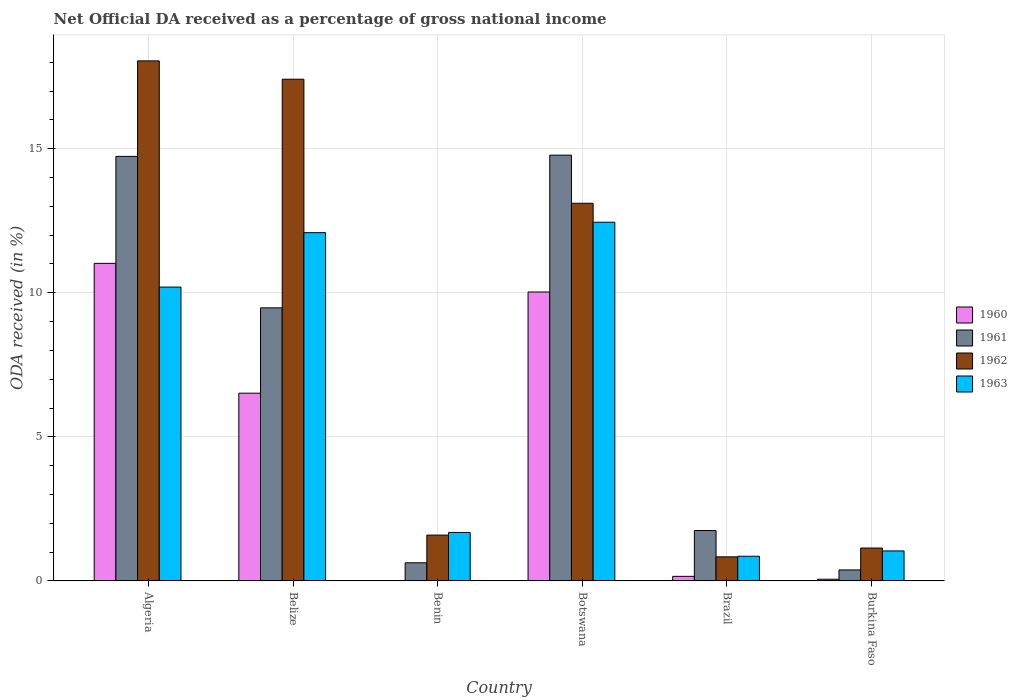How many different coloured bars are there?
Offer a very short reply. 4. Are the number of bars per tick equal to the number of legend labels?
Your answer should be compact. Yes. What is the label of the 3rd group of bars from the left?
Provide a succinct answer. Benin. What is the net official DA received in 1961 in Benin?
Keep it short and to the point. 0.63. Across all countries, what is the maximum net official DA received in 1961?
Offer a terse response. 14.78. Across all countries, what is the minimum net official DA received in 1960?
Offer a terse response. 0.01. In which country was the net official DA received in 1963 maximum?
Provide a succinct answer. Botswana. In which country was the net official DA received in 1960 minimum?
Provide a short and direct response. Benin. What is the total net official DA received in 1961 in the graph?
Your response must be concise. 41.75. What is the difference between the net official DA received in 1960 in Belize and that in Burkina Faso?
Keep it short and to the point. 6.46. What is the difference between the net official DA received in 1963 in Botswana and the net official DA received in 1962 in Belize?
Your response must be concise. -4.96. What is the average net official DA received in 1961 per country?
Provide a short and direct response. 6.96. What is the difference between the net official DA received of/in 1960 and net official DA received of/in 1962 in Algeria?
Ensure brevity in your answer.  -7.03. What is the ratio of the net official DA received in 1962 in Algeria to that in Brazil?
Provide a succinct answer. 21.59. Is the difference between the net official DA received in 1960 in Algeria and Benin greater than the difference between the net official DA received in 1962 in Algeria and Benin?
Give a very brief answer. No. What is the difference between the highest and the second highest net official DA received in 1963?
Offer a terse response. -2.25. What is the difference between the highest and the lowest net official DA received in 1961?
Give a very brief answer. 14.4. In how many countries, is the net official DA received in 1961 greater than the average net official DA received in 1961 taken over all countries?
Make the answer very short. 3. Is the sum of the net official DA received in 1962 in Belize and Burkina Faso greater than the maximum net official DA received in 1960 across all countries?
Give a very brief answer. Yes. Is it the case that in every country, the sum of the net official DA received in 1960 and net official DA received in 1962 is greater than the sum of net official DA received in 1961 and net official DA received in 1963?
Offer a very short reply. No. Is it the case that in every country, the sum of the net official DA received in 1961 and net official DA received in 1963 is greater than the net official DA received in 1960?
Your answer should be compact. Yes. Are the values on the major ticks of Y-axis written in scientific E-notation?
Give a very brief answer. No. Does the graph contain grids?
Provide a succinct answer. Yes. Where does the legend appear in the graph?
Your response must be concise. Center right. How are the legend labels stacked?
Provide a succinct answer. Vertical. What is the title of the graph?
Your answer should be compact. Net Official DA received as a percentage of gross national income. What is the label or title of the Y-axis?
Keep it short and to the point. ODA received (in %). What is the ODA received (in %) of 1960 in Algeria?
Provide a succinct answer. 11.02. What is the ODA received (in %) in 1961 in Algeria?
Your answer should be very brief. 14.73. What is the ODA received (in %) of 1962 in Algeria?
Make the answer very short. 18.05. What is the ODA received (in %) in 1963 in Algeria?
Give a very brief answer. 10.2. What is the ODA received (in %) of 1960 in Belize?
Keep it short and to the point. 6.52. What is the ODA received (in %) in 1961 in Belize?
Offer a terse response. 9.48. What is the ODA received (in %) of 1962 in Belize?
Provide a short and direct response. 17.41. What is the ODA received (in %) in 1963 in Belize?
Provide a short and direct response. 12.09. What is the ODA received (in %) in 1960 in Benin?
Make the answer very short. 0.01. What is the ODA received (in %) in 1961 in Benin?
Your answer should be compact. 0.63. What is the ODA received (in %) in 1962 in Benin?
Offer a very short reply. 1.59. What is the ODA received (in %) of 1963 in Benin?
Your answer should be very brief. 1.68. What is the ODA received (in %) of 1960 in Botswana?
Give a very brief answer. 10.03. What is the ODA received (in %) of 1961 in Botswana?
Provide a short and direct response. 14.78. What is the ODA received (in %) in 1962 in Botswana?
Offer a very short reply. 13.11. What is the ODA received (in %) of 1963 in Botswana?
Make the answer very short. 12.45. What is the ODA received (in %) of 1960 in Brazil?
Your answer should be very brief. 0.16. What is the ODA received (in %) of 1961 in Brazil?
Offer a very short reply. 1.75. What is the ODA received (in %) in 1962 in Brazil?
Provide a short and direct response. 0.84. What is the ODA received (in %) in 1963 in Brazil?
Your answer should be compact. 0.86. What is the ODA received (in %) of 1960 in Burkina Faso?
Offer a terse response. 0.06. What is the ODA received (in %) of 1961 in Burkina Faso?
Make the answer very short. 0.38. What is the ODA received (in %) in 1962 in Burkina Faso?
Your answer should be very brief. 1.14. What is the ODA received (in %) of 1963 in Burkina Faso?
Your response must be concise. 1.04. Across all countries, what is the maximum ODA received (in %) in 1960?
Give a very brief answer. 11.02. Across all countries, what is the maximum ODA received (in %) in 1961?
Offer a terse response. 14.78. Across all countries, what is the maximum ODA received (in %) of 1962?
Your answer should be very brief. 18.05. Across all countries, what is the maximum ODA received (in %) in 1963?
Provide a short and direct response. 12.45. Across all countries, what is the minimum ODA received (in %) in 1960?
Provide a succinct answer. 0.01. Across all countries, what is the minimum ODA received (in %) of 1961?
Offer a very short reply. 0.38. Across all countries, what is the minimum ODA received (in %) of 1962?
Your answer should be compact. 0.84. Across all countries, what is the minimum ODA received (in %) in 1963?
Make the answer very short. 0.86. What is the total ODA received (in %) of 1960 in the graph?
Make the answer very short. 27.79. What is the total ODA received (in %) in 1961 in the graph?
Your response must be concise. 41.75. What is the total ODA received (in %) of 1962 in the graph?
Ensure brevity in your answer.  52.14. What is the total ODA received (in %) in 1963 in the graph?
Ensure brevity in your answer.  38.32. What is the difference between the ODA received (in %) in 1960 in Algeria and that in Belize?
Give a very brief answer. 4.51. What is the difference between the ODA received (in %) of 1961 in Algeria and that in Belize?
Make the answer very short. 5.26. What is the difference between the ODA received (in %) of 1962 in Algeria and that in Belize?
Give a very brief answer. 0.64. What is the difference between the ODA received (in %) of 1963 in Algeria and that in Belize?
Offer a very short reply. -1.89. What is the difference between the ODA received (in %) in 1960 in Algeria and that in Benin?
Offer a terse response. 11.01. What is the difference between the ODA received (in %) of 1961 in Algeria and that in Benin?
Give a very brief answer. 14.1. What is the difference between the ODA received (in %) in 1962 in Algeria and that in Benin?
Your answer should be very brief. 16.46. What is the difference between the ODA received (in %) of 1963 in Algeria and that in Benin?
Give a very brief answer. 8.52. What is the difference between the ODA received (in %) in 1961 in Algeria and that in Botswana?
Your response must be concise. -0.04. What is the difference between the ODA received (in %) of 1962 in Algeria and that in Botswana?
Your answer should be very brief. 4.94. What is the difference between the ODA received (in %) in 1963 in Algeria and that in Botswana?
Provide a succinct answer. -2.25. What is the difference between the ODA received (in %) of 1960 in Algeria and that in Brazil?
Your answer should be very brief. 10.86. What is the difference between the ODA received (in %) in 1961 in Algeria and that in Brazil?
Keep it short and to the point. 12.98. What is the difference between the ODA received (in %) of 1962 in Algeria and that in Brazil?
Ensure brevity in your answer.  17.21. What is the difference between the ODA received (in %) of 1963 in Algeria and that in Brazil?
Ensure brevity in your answer.  9.34. What is the difference between the ODA received (in %) of 1960 in Algeria and that in Burkina Faso?
Your response must be concise. 10.96. What is the difference between the ODA received (in %) of 1961 in Algeria and that in Burkina Faso?
Your answer should be compact. 14.35. What is the difference between the ODA received (in %) in 1962 in Algeria and that in Burkina Faso?
Your answer should be very brief. 16.91. What is the difference between the ODA received (in %) of 1963 in Algeria and that in Burkina Faso?
Offer a terse response. 9.16. What is the difference between the ODA received (in %) in 1960 in Belize and that in Benin?
Ensure brevity in your answer.  6.51. What is the difference between the ODA received (in %) of 1961 in Belize and that in Benin?
Provide a short and direct response. 8.85. What is the difference between the ODA received (in %) in 1962 in Belize and that in Benin?
Ensure brevity in your answer.  15.82. What is the difference between the ODA received (in %) in 1963 in Belize and that in Benin?
Provide a succinct answer. 10.4. What is the difference between the ODA received (in %) in 1960 in Belize and that in Botswana?
Keep it short and to the point. -3.51. What is the difference between the ODA received (in %) in 1961 in Belize and that in Botswana?
Offer a very short reply. -5.3. What is the difference between the ODA received (in %) of 1962 in Belize and that in Botswana?
Provide a succinct answer. 4.31. What is the difference between the ODA received (in %) in 1963 in Belize and that in Botswana?
Offer a terse response. -0.36. What is the difference between the ODA received (in %) in 1960 in Belize and that in Brazil?
Ensure brevity in your answer.  6.36. What is the difference between the ODA received (in %) in 1961 in Belize and that in Brazil?
Give a very brief answer. 7.73. What is the difference between the ODA received (in %) of 1962 in Belize and that in Brazil?
Give a very brief answer. 16.58. What is the difference between the ODA received (in %) of 1963 in Belize and that in Brazil?
Ensure brevity in your answer.  11.23. What is the difference between the ODA received (in %) of 1960 in Belize and that in Burkina Faso?
Provide a succinct answer. 6.46. What is the difference between the ODA received (in %) in 1961 in Belize and that in Burkina Faso?
Provide a short and direct response. 9.1. What is the difference between the ODA received (in %) in 1962 in Belize and that in Burkina Faso?
Offer a terse response. 16.27. What is the difference between the ODA received (in %) of 1963 in Belize and that in Burkina Faso?
Give a very brief answer. 11.05. What is the difference between the ODA received (in %) in 1960 in Benin and that in Botswana?
Make the answer very short. -10.02. What is the difference between the ODA received (in %) in 1961 in Benin and that in Botswana?
Provide a succinct answer. -14.15. What is the difference between the ODA received (in %) in 1962 in Benin and that in Botswana?
Your answer should be compact. -11.52. What is the difference between the ODA received (in %) of 1963 in Benin and that in Botswana?
Your response must be concise. -10.77. What is the difference between the ODA received (in %) of 1960 in Benin and that in Brazil?
Offer a terse response. -0.15. What is the difference between the ODA received (in %) of 1961 in Benin and that in Brazil?
Make the answer very short. -1.12. What is the difference between the ODA received (in %) of 1962 in Benin and that in Brazil?
Ensure brevity in your answer.  0.76. What is the difference between the ODA received (in %) of 1963 in Benin and that in Brazil?
Provide a succinct answer. 0.83. What is the difference between the ODA received (in %) of 1960 in Benin and that in Burkina Faso?
Give a very brief answer. -0.05. What is the difference between the ODA received (in %) in 1961 in Benin and that in Burkina Faso?
Provide a short and direct response. 0.25. What is the difference between the ODA received (in %) of 1962 in Benin and that in Burkina Faso?
Provide a succinct answer. 0.45. What is the difference between the ODA received (in %) in 1963 in Benin and that in Burkina Faso?
Provide a succinct answer. 0.64. What is the difference between the ODA received (in %) of 1960 in Botswana and that in Brazil?
Make the answer very short. 9.87. What is the difference between the ODA received (in %) of 1961 in Botswana and that in Brazil?
Give a very brief answer. 13.03. What is the difference between the ODA received (in %) in 1962 in Botswana and that in Brazil?
Give a very brief answer. 12.27. What is the difference between the ODA received (in %) in 1963 in Botswana and that in Brazil?
Keep it short and to the point. 11.59. What is the difference between the ODA received (in %) of 1960 in Botswana and that in Burkina Faso?
Keep it short and to the point. 9.97. What is the difference between the ODA received (in %) in 1961 in Botswana and that in Burkina Faso?
Ensure brevity in your answer.  14.39. What is the difference between the ODA received (in %) of 1962 in Botswana and that in Burkina Faso?
Make the answer very short. 11.97. What is the difference between the ODA received (in %) in 1963 in Botswana and that in Burkina Faso?
Make the answer very short. 11.41. What is the difference between the ODA received (in %) of 1960 in Brazil and that in Burkina Faso?
Your response must be concise. 0.1. What is the difference between the ODA received (in %) of 1961 in Brazil and that in Burkina Faso?
Provide a succinct answer. 1.37. What is the difference between the ODA received (in %) in 1962 in Brazil and that in Burkina Faso?
Your answer should be compact. -0.31. What is the difference between the ODA received (in %) of 1963 in Brazil and that in Burkina Faso?
Give a very brief answer. -0.18. What is the difference between the ODA received (in %) in 1960 in Algeria and the ODA received (in %) in 1961 in Belize?
Your response must be concise. 1.54. What is the difference between the ODA received (in %) of 1960 in Algeria and the ODA received (in %) of 1962 in Belize?
Your answer should be very brief. -6.39. What is the difference between the ODA received (in %) of 1960 in Algeria and the ODA received (in %) of 1963 in Belize?
Ensure brevity in your answer.  -1.07. What is the difference between the ODA received (in %) in 1961 in Algeria and the ODA received (in %) in 1962 in Belize?
Give a very brief answer. -2.68. What is the difference between the ODA received (in %) in 1961 in Algeria and the ODA received (in %) in 1963 in Belize?
Offer a terse response. 2.65. What is the difference between the ODA received (in %) of 1962 in Algeria and the ODA received (in %) of 1963 in Belize?
Your response must be concise. 5.96. What is the difference between the ODA received (in %) in 1960 in Algeria and the ODA received (in %) in 1961 in Benin?
Give a very brief answer. 10.39. What is the difference between the ODA received (in %) in 1960 in Algeria and the ODA received (in %) in 1962 in Benin?
Give a very brief answer. 9.43. What is the difference between the ODA received (in %) in 1960 in Algeria and the ODA received (in %) in 1963 in Benin?
Provide a short and direct response. 9.34. What is the difference between the ODA received (in %) in 1961 in Algeria and the ODA received (in %) in 1962 in Benin?
Make the answer very short. 13.14. What is the difference between the ODA received (in %) of 1961 in Algeria and the ODA received (in %) of 1963 in Benin?
Your response must be concise. 13.05. What is the difference between the ODA received (in %) of 1962 in Algeria and the ODA received (in %) of 1963 in Benin?
Your answer should be very brief. 16.37. What is the difference between the ODA received (in %) in 1960 in Algeria and the ODA received (in %) in 1961 in Botswana?
Your answer should be compact. -3.76. What is the difference between the ODA received (in %) in 1960 in Algeria and the ODA received (in %) in 1962 in Botswana?
Your response must be concise. -2.09. What is the difference between the ODA received (in %) in 1960 in Algeria and the ODA received (in %) in 1963 in Botswana?
Provide a short and direct response. -1.43. What is the difference between the ODA received (in %) in 1961 in Algeria and the ODA received (in %) in 1962 in Botswana?
Give a very brief answer. 1.63. What is the difference between the ODA received (in %) in 1961 in Algeria and the ODA received (in %) in 1963 in Botswana?
Make the answer very short. 2.28. What is the difference between the ODA received (in %) of 1962 in Algeria and the ODA received (in %) of 1963 in Botswana?
Your response must be concise. 5.6. What is the difference between the ODA received (in %) of 1960 in Algeria and the ODA received (in %) of 1961 in Brazil?
Ensure brevity in your answer.  9.27. What is the difference between the ODA received (in %) in 1960 in Algeria and the ODA received (in %) in 1962 in Brazil?
Ensure brevity in your answer.  10.19. What is the difference between the ODA received (in %) in 1960 in Algeria and the ODA received (in %) in 1963 in Brazil?
Keep it short and to the point. 10.16. What is the difference between the ODA received (in %) of 1961 in Algeria and the ODA received (in %) of 1962 in Brazil?
Provide a short and direct response. 13.9. What is the difference between the ODA received (in %) of 1961 in Algeria and the ODA received (in %) of 1963 in Brazil?
Your answer should be very brief. 13.88. What is the difference between the ODA received (in %) in 1962 in Algeria and the ODA received (in %) in 1963 in Brazil?
Provide a short and direct response. 17.19. What is the difference between the ODA received (in %) of 1960 in Algeria and the ODA received (in %) of 1961 in Burkina Faso?
Give a very brief answer. 10.64. What is the difference between the ODA received (in %) in 1960 in Algeria and the ODA received (in %) in 1962 in Burkina Faso?
Offer a very short reply. 9.88. What is the difference between the ODA received (in %) in 1960 in Algeria and the ODA received (in %) in 1963 in Burkina Faso?
Your answer should be compact. 9.98. What is the difference between the ODA received (in %) in 1961 in Algeria and the ODA received (in %) in 1962 in Burkina Faso?
Your answer should be very brief. 13.59. What is the difference between the ODA received (in %) of 1961 in Algeria and the ODA received (in %) of 1963 in Burkina Faso?
Your answer should be compact. 13.69. What is the difference between the ODA received (in %) in 1962 in Algeria and the ODA received (in %) in 1963 in Burkina Faso?
Ensure brevity in your answer.  17.01. What is the difference between the ODA received (in %) of 1960 in Belize and the ODA received (in %) of 1961 in Benin?
Offer a very short reply. 5.89. What is the difference between the ODA received (in %) in 1960 in Belize and the ODA received (in %) in 1962 in Benin?
Give a very brief answer. 4.92. What is the difference between the ODA received (in %) of 1960 in Belize and the ODA received (in %) of 1963 in Benin?
Your answer should be very brief. 4.83. What is the difference between the ODA received (in %) of 1961 in Belize and the ODA received (in %) of 1962 in Benin?
Give a very brief answer. 7.89. What is the difference between the ODA received (in %) in 1961 in Belize and the ODA received (in %) in 1963 in Benin?
Make the answer very short. 7.79. What is the difference between the ODA received (in %) in 1962 in Belize and the ODA received (in %) in 1963 in Benin?
Make the answer very short. 15.73. What is the difference between the ODA received (in %) in 1960 in Belize and the ODA received (in %) in 1961 in Botswana?
Make the answer very short. -8.26. What is the difference between the ODA received (in %) in 1960 in Belize and the ODA received (in %) in 1962 in Botswana?
Your answer should be compact. -6.59. What is the difference between the ODA received (in %) of 1960 in Belize and the ODA received (in %) of 1963 in Botswana?
Provide a succinct answer. -5.93. What is the difference between the ODA received (in %) in 1961 in Belize and the ODA received (in %) in 1962 in Botswana?
Give a very brief answer. -3.63. What is the difference between the ODA received (in %) in 1961 in Belize and the ODA received (in %) in 1963 in Botswana?
Your answer should be very brief. -2.97. What is the difference between the ODA received (in %) of 1962 in Belize and the ODA received (in %) of 1963 in Botswana?
Your answer should be very brief. 4.96. What is the difference between the ODA received (in %) of 1960 in Belize and the ODA received (in %) of 1961 in Brazil?
Give a very brief answer. 4.77. What is the difference between the ODA received (in %) of 1960 in Belize and the ODA received (in %) of 1962 in Brazil?
Provide a succinct answer. 5.68. What is the difference between the ODA received (in %) of 1960 in Belize and the ODA received (in %) of 1963 in Brazil?
Your response must be concise. 5.66. What is the difference between the ODA received (in %) of 1961 in Belize and the ODA received (in %) of 1962 in Brazil?
Ensure brevity in your answer.  8.64. What is the difference between the ODA received (in %) of 1961 in Belize and the ODA received (in %) of 1963 in Brazil?
Keep it short and to the point. 8.62. What is the difference between the ODA received (in %) in 1962 in Belize and the ODA received (in %) in 1963 in Brazil?
Keep it short and to the point. 16.56. What is the difference between the ODA received (in %) in 1960 in Belize and the ODA received (in %) in 1961 in Burkina Faso?
Give a very brief answer. 6.13. What is the difference between the ODA received (in %) of 1960 in Belize and the ODA received (in %) of 1962 in Burkina Faso?
Offer a very short reply. 5.37. What is the difference between the ODA received (in %) of 1960 in Belize and the ODA received (in %) of 1963 in Burkina Faso?
Your answer should be very brief. 5.47. What is the difference between the ODA received (in %) of 1961 in Belize and the ODA received (in %) of 1962 in Burkina Faso?
Your answer should be compact. 8.34. What is the difference between the ODA received (in %) of 1961 in Belize and the ODA received (in %) of 1963 in Burkina Faso?
Offer a terse response. 8.44. What is the difference between the ODA received (in %) in 1962 in Belize and the ODA received (in %) in 1963 in Burkina Faso?
Your answer should be very brief. 16.37. What is the difference between the ODA received (in %) in 1960 in Benin and the ODA received (in %) in 1961 in Botswana?
Offer a very short reply. -14.77. What is the difference between the ODA received (in %) in 1960 in Benin and the ODA received (in %) in 1962 in Botswana?
Your response must be concise. -13.1. What is the difference between the ODA received (in %) in 1960 in Benin and the ODA received (in %) in 1963 in Botswana?
Give a very brief answer. -12.44. What is the difference between the ODA received (in %) of 1961 in Benin and the ODA received (in %) of 1962 in Botswana?
Your answer should be compact. -12.48. What is the difference between the ODA received (in %) of 1961 in Benin and the ODA received (in %) of 1963 in Botswana?
Provide a succinct answer. -11.82. What is the difference between the ODA received (in %) of 1962 in Benin and the ODA received (in %) of 1963 in Botswana?
Ensure brevity in your answer.  -10.86. What is the difference between the ODA received (in %) of 1960 in Benin and the ODA received (in %) of 1961 in Brazil?
Keep it short and to the point. -1.74. What is the difference between the ODA received (in %) of 1960 in Benin and the ODA received (in %) of 1962 in Brazil?
Your answer should be very brief. -0.83. What is the difference between the ODA received (in %) in 1960 in Benin and the ODA received (in %) in 1963 in Brazil?
Your answer should be very brief. -0.85. What is the difference between the ODA received (in %) of 1961 in Benin and the ODA received (in %) of 1962 in Brazil?
Ensure brevity in your answer.  -0.21. What is the difference between the ODA received (in %) of 1961 in Benin and the ODA received (in %) of 1963 in Brazil?
Your response must be concise. -0.23. What is the difference between the ODA received (in %) of 1962 in Benin and the ODA received (in %) of 1963 in Brazil?
Keep it short and to the point. 0.73. What is the difference between the ODA received (in %) of 1960 in Benin and the ODA received (in %) of 1961 in Burkina Faso?
Offer a very short reply. -0.37. What is the difference between the ODA received (in %) of 1960 in Benin and the ODA received (in %) of 1962 in Burkina Faso?
Provide a succinct answer. -1.13. What is the difference between the ODA received (in %) of 1960 in Benin and the ODA received (in %) of 1963 in Burkina Faso?
Give a very brief answer. -1.03. What is the difference between the ODA received (in %) of 1961 in Benin and the ODA received (in %) of 1962 in Burkina Faso?
Provide a succinct answer. -0.51. What is the difference between the ODA received (in %) in 1961 in Benin and the ODA received (in %) in 1963 in Burkina Faso?
Ensure brevity in your answer.  -0.41. What is the difference between the ODA received (in %) of 1962 in Benin and the ODA received (in %) of 1963 in Burkina Faso?
Make the answer very short. 0.55. What is the difference between the ODA received (in %) of 1960 in Botswana and the ODA received (in %) of 1961 in Brazil?
Your answer should be very brief. 8.28. What is the difference between the ODA received (in %) in 1960 in Botswana and the ODA received (in %) in 1962 in Brazil?
Your response must be concise. 9.19. What is the difference between the ODA received (in %) of 1960 in Botswana and the ODA received (in %) of 1963 in Brazil?
Provide a succinct answer. 9.17. What is the difference between the ODA received (in %) in 1961 in Botswana and the ODA received (in %) in 1962 in Brazil?
Provide a succinct answer. 13.94. What is the difference between the ODA received (in %) in 1961 in Botswana and the ODA received (in %) in 1963 in Brazil?
Offer a very short reply. 13.92. What is the difference between the ODA received (in %) in 1962 in Botswana and the ODA received (in %) in 1963 in Brazil?
Your response must be concise. 12.25. What is the difference between the ODA received (in %) of 1960 in Botswana and the ODA received (in %) of 1961 in Burkina Faso?
Your answer should be compact. 9.65. What is the difference between the ODA received (in %) in 1960 in Botswana and the ODA received (in %) in 1962 in Burkina Faso?
Keep it short and to the point. 8.89. What is the difference between the ODA received (in %) of 1960 in Botswana and the ODA received (in %) of 1963 in Burkina Faso?
Your response must be concise. 8.99. What is the difference between the ODA received (in %) in 1961 in Botswana and the ODA received (in %) in 1962 in Burkina Faso?
Your answer should be compact. 13.64. What is the difference between the ODA received (in %) of 1961 in Botswana and the ODA received (in %) of 1963 in Burkina Faso?
Ensure brevity in your answer.  13.74. What is the difference between the ODA received (in %) in 1962 in Botswana and the ODA received (in %) in 1963 in Burkina Faso?
Make the answer very short. 12.07. What is the difference between the ODA received (in %) of 1960 in Brazil and the ODA received (in %) of 1961 in Burkina Faso?
Your answer should be compact. -0.22. What is the difference between the ODA received (in %) of 1960 in Brazil and the ODA received (in %) of 1962 in Burkina Faso?
Provide a short and direct response. -0.98. What is the difference between the ODA received (in %) of 1960 in Brazil and the ODA received (in %) of 1963 in Burkina Faso?
Offer a terse response. -0.88. What is the difference between the ODA received (in %) in 1961 in Brazil and the ODA received (in %) in 1962 in Burkina Faso?
Make the answer very short. 0.61. What is the difference between the ODA received (in %) in 1961 in Brazil and the ODA received (in %) in 1963 in Burkina Faso?
Make the answer very short. 0.71. What is the difference between the ODA received (in %) in 1962 in Brazil and the ODA received (in %) in 1963 in Burkina Faso?
Ensure brevity in your answer.  -0.21. What is the average ODA received (in %) of 1960 per country?
Keep it short and to the point. 4.63. What is the average ODA received (in %) in 1961 per country?
Your response must be concise. 6.96. What is the average ODA received (in %) in 1962 per country?
Your answer should be compact. 8.69. What is the average ODA received (in %) in 1963 per country?
Provide a short and direct response. 6.39. What is the difference between the ODA received (in %) in 1960 and ODA received (in %) in 1961 in Algeria?
Offer a very short reply. -3.71. What is the difference between the ODA received (in %) in 1960 and ODA received (in %) in 1962 in Algeria?
Your answer should be very brief. -7.03. What is the difference between the ODA received (in %) of 1960 and ODA received (in %) of 1963 in Algeria?
Make the answer very short. 0.82. What is the difference between the ODA received (in %) in 1961 and ODA received (in %) in 1962 in Algeria?
Give a very brief answer. -3.31. What is the difference between the ODA received (in %) of 1961 and ODA received (in %) of 1963 in Algeria?
Your answer should be very brief. 4.54. What is the difference between the ODA received (in %) of 1962 and ODA received (in %) of 1963 in Algeria?
Keep it short and to the point. 7.85. What is the difference between the ODA received (in %) in 1960 and ODA received (in %) in 1961 in Belize?
Give a very brief answer. -2.96. What is the difference between the ODA received (in %) in 1960 and ODA received (in %) in 1962 in Belize?
Provide a short and direct response. -10.9. What is the difference between the ODA received (in %) of 1960 and ODA received (in %) of 1963 in Belize?
Give a very brief answer. -5.57. What is the difference between the ODA received (in %) in 1961 and ODA received (in %) in 1962 in Belize?
Give a very brief answer. -7.93. What is the difference between the ODA received (in %) of 1961 and ODA received (in %) of 1963 in Belize?
Make the answer very short. -2.61. What is the difference between the ODA received (in %) of 1962 and ODA received (in %) of 1963 in Belize?
Provide a succinct answer. 5.32. What is the difference between the ODA received (in %) of 1960 and ODA received (in %) of 1961 in Benin?
Provide a succinct answer. -0.62. What is the difference between the ODA received (in %) of 1960 and ODA received (in %) of 1962 in Benin?
Provide a short and direct response. -1.58. What is the difference between the ODA received (in %) of 1960 and ODA received (in %) of 1963 in Benin?
Provide a short and direct response. -1.67. What is the difference between the ODA received (in %) of 1961 and ODA received (in %) of 1962 in Benin?
Give a very brief answer. -0.96. What is the difference between the ODA received (in %) of 1961 and ODA received (in %) of 1963 in Benin?
Give a very brief answer. -1.05. What is the difference between the ODA received (in %) in 1962 and ODA received (in %) in 1963 in Benin?
Provide a short and direct response. -0.09. What is the difference between the ODA received (in %) of 1960 and ODA received (in %) of 1961 in Botswana?
Give a very brief answer. -4.75. What is the difference between the ODA received (in %) of 1960 and ODA received (in %) of 1962 in Botswana?
Your answer should be compact. -3.08. What is the difference between the ODA received (in %) in 1960 and ODA received (in %) in 1963 in Botswana?
Your answer should be very brief. -2.42. What is the difference between the ODA received (in %) of 1961 and ODA received (in %) of 1962 in Botswana?
Provide a short and direct response. 1.67. What is the difference between the ODA received (in %) in 1961 and ODA received (in %) in 1963 in Botswana?
Your answer should be compact. 2.33. What is the difference between the ODA received (in %) of 1962 and ODA received (in %) of 1963 in Botswana?
Your answer should be very brief. 0.66. What is the difference between the ODA received (in %) in 1960 and ODA received (in %) in 1961 in Brazil?
Your answer should be very brief. -1.59. What is the difference between the ODA received (in %) of 1960 and ODA received (in %) of 1962 in Brazil?
Keep it short and to the point. -0.68. What is the difference between the ODA received (in %) of 1960 and ODA received (in %) of 1963 in Brazil?
Provide a succinct answer. -0.7. What is the difference between the ODA received (in %) of 1961 and ODA received (in %) of 1962 in Brazil?
Offer a very short reply. 0.91. What is the difference between the ODA received (in %) in 1961 and ODA received (in %) in 1963 in Brazil?
Your answer should be very brief. 0.89. What is the difference between the ODA received (in %) of 1962 and ODA received (in %) of 1963 in Brazil?
Your response must be concise. -0.02. What is the difference between the ODA received (in %) of 1960 and ODA received (in %) of 1961 in Burkina Faso?
Offer a very short reply. -0.32. What is the difference between the ODA received (in %) in 1960 and ODA received (in %) in 1962 in Burkina Faso?
Offer a terse response. -1.08. What is the difference between the ODA received (in %) of 1960 and ODA received (in %) of 1963 in Burkina Faso?
Provide a short and direct response. -0.98. What is the difference between the ODA received (in %) of 1961 and ODA received (in %) of 1962 in Burkina Faso?
Your response must be concise. -0.76. What is the difference between the ODA received (in %) of 1961 and ODA received (in %) of 1963 in Burkina Faso?
Your answer should be very brief. -0.66. What is the difference between the ODA received (in %) in 1962 and ODA received (in %) in 1963 in Burkina Faso?
Keep it short and to the point. 0.1. What is the ratio of the ODA received (in %) in 1960 in Algeria to that in Belize?
Provide a short and direct response. 1.69. What is the ratio of the ODA received (in %) in 1961 in Algeria to that in Belize?
Give a very brief answer. 1.55. What is the ratio of the ODA received (in %) of 1962 in Algeria to that in Belize?
Your response must be concise. 1.04. What is the ratio of the ODA received (in %) of 1963 in Algeria to that in Belize?
Give a very brief answer. 0.84. What is the ratio of the ODA received (in %) of 1960 in Algeria to that in Benin?
Your answer should be very brief. 1242.53. What is the ratio of the ODA received (in %) of 1961 in Algeria to that in Benin?
Offer a terse response. 23.39. What is the ratio of the ODA received (in %) in 1962 in Algeria to that in Benin?
Give a very brief answer. 11.34. What is the ratio of the ODA received (in %) in 1963 in Algeria to that in Benin?
Your answer should be very brief. 6.06. What is the ratio of the ODA received (in %) in 1960 in Algeria to that in Botswana?
Make the answer very short. 1.1. What is the ratio of the ODA received (in %) in 1962 in Algeria to that in Botswana?
Your answer should be compact. 1.38. What is the ratio of the ODA received (in %) in 1963 in Algeria to that in Botswana?
Your answer should be very brief. 0.82. What is the ratio of the ODA received (in %) in 1960 in Algeria to that in Brazil?
Offer a terse response. 69.32. What is the ratio of the ODA received (in %) of 1961 in Algeria to that in Brazil?
Offer a terse response. 8.42. What is the ratio of the ODA received (in %) of 1962 in Algeria to that in Brazil?
Offer a terse response. 21.59. What is the ratio of the ODA received (in %) of 1963 in Algeria to that in Brazil?
Your response must be concise. 11.9. What is the ratio of the ODA received (in %) in 1960 in Algeria to that in Burkina Faso?
Your response must be concise. 184.54. What is the ratio of the ODA received (in %) of 1961 in Algeria to that in Burkina Faso?
Provide a short and direct response. 38.57. What is the ratio of the ODA received (in %) in 1962 in Algeria to that in Burkina Faso?
Make the answer very short. 15.81. What is the ratio of the ODA received (in %) of 1963 in Algeria to that in Burkina Faso?
Keep it short and to the point. 9.79. What is the ratio of the ODA received (in %) in 1960 in Belize to that in Benin?
Provide a succinct answer. 734.62. What is the ratio of the ODA received (in %) of 1961 in Belize to that in Benin?
Give a very brief answer. 15.04. What is the ratio of the ODA received (in %) of 1962 in Belize to that in Benin?
Provide a succinct answer. 10.94. What is the ratio of the ODA received (in %) of 1963 in Belize to that in Benin?
Offer a terse response. 7.18. What is the ratio of the ODA received (in %) in 1960 in Belize to that in Botswana?
Your answer should be very brief. 0.65. What is the ratio of the ODA received (in %) in 1961 in Belize to that in Botswana?
Your answer should be compact. 0.64. What is the ratio of the ODA received (in %) of 1962 in Belize to that in Botswana?
Your response must be concise. 1.33. What is the ratio of the ODA received (in %) in 1963 in Belize to that in Botswana?
Offer a very short reply. 0.97. What is the ratio of the ODA received (in %) in 1960 in Belize to that in Brazil?
Offer a very short reply. 40.99. What is the ratio of the ODA received (in %) of 1961 in Belize to that in Brazil?
Your answer should be compact. 5.42. What is the ratio of the ODA received (in %) in 1962 in Belize to that in Brazil?
Provide a short and direct response. 20.83. What is the ratio of the ODA received (in %) of 1963 in Belize to that in Brazil?
Give a very brief answer. 14.11. What is the ratio of the ODA received (in %) in 1960 in Belize to that in Burkina Faso?
Keep it short and to the point. 109.11. What is the ratio of the ODA received (in %) of 1961 in Belize to that in Burkina Faso?
Provide a succinct answer. 24.81. What is the ratio of the ODA received (in %) in 1962 in Belize to that in Burkina Faso?
Your response must be concise. 15.25. What is the ratio of the ODA received (in %) in 1963 in Belize to that in Burkina Faso?
Keep it short and to the point. 11.6. What is the ratio of the ODA received (in %) in 1960 in Benin to that in Botswana?
Keep it short and to the point. 0. What is the ratio of the ODA received (in %) in 1961 in Benin to that in Botswana?
Offer a very short reply. 0.04. What is the ratio of the ODA received (in %) in 1962 in Benin to that in Botswana?
Keep it short and to the point. 0.12. What is the ratio of the ODA received (in %) of 1963 in Benin to that in Botswana?
Keep it short and to the point. 0.14. What is the ratio of the ODA received (in %) of 1960 in Benin to that in Brazil?
Provide a short and direct response. 0.06. What is the ratio of the ODA received (in %) of 1961 in Benin to that in Brazil?
Give a very brief answer. 0.36. What is the ratio of the ODA received (in %) in 1962 in Benin to that in Brazil?
Provide a succinct answer. 1.9. What is the ratio of the ODA received (in %) of 1963 in Benin to that in Brazil?
Make the answer very short. 1.96. What is the ratio of the ODA received (in %) in 1960 in Benin to that in Burkina Faso?
Offer a terse response. 0.15. What is the ratio of the ODA received (in %) in 1961 in Benin to that in Burkina Faso?
Offer a very short reply. 1.65. What is the ratio of the ODA received (in %) of 1962 in Benin to that in Burkina Faso?
Keep it short and to the point. 1.39. What is the ratio of the ODA received (in %) of 1963 in Benin to that in Burkina Faso?
Ensure brevity in your answer.  1.62. What is the ratio of the ODA received (in %) in 1960 in Botswana to that in Brazil?
Offer a very short reply. 63.08. What is the ratio of the ODA received (in %) in 1961 in Botswana to that in Brazil?
Keep it short and to the point. 8.45. What is the ratio of the ODA received (in %) of 1962 in Botswana to that in Brazil?
Keep it short and to the point. 15.68. What is the ratio of the ODA received (in %) of 1963 in Botswana to that in Brazil?
Your response must be concise. 14.53. What is the ratio of the ODA received (in %) in 1960 in Botswana to that in Burkina Faso?
Your response must be concise. 167.91. What is the ratio of the ODA received (in %) of 1961 in Botswana to that in Burkina Faso?
Your answer should be very brief. 38.69. What is the ratio of the ODA received (in %) in 1962 in Botswana to that in Burkina Faso?
Your answer should be compact. 11.48. What is the ratio of the ODA received (in %) of 1963 in Botswana to that in Burkina Faso?
Make the answer very short. 11.95. What is the ratio of the ODA received (in %) in 1960 in Brazil to that in Burkina Faso?
Keep it short and to the point. 2.66. What is the ratio of the ODA received (in %) of 1961 in Brazil to that in Burkina Faso?
Give a very brief answer. 4.58. What is the ratio of the ODA received (in %) of 1962 in Brazil to that in Burkina Faso?
Your response must be concise. 0.73. What is the ratio of the ODA received (in %) of 1963 in Brazil to that in Burkina Faso?
Provide a short and direct response. 0.82. What is the difference between the highest and the second highest ODA received (in %) in 1960?
Provide a succinct answer. 0.99. What is the difference between the highest and the second highest ODA received (in %) of 1961?
Your answer should be very brief. 0.04. What is the difference between the highest and the second highest ODA received (in %) in 1962?
Offer a terse response. 0.64. What is the difference between the highest and the second highest ODA received (in %) in 1963?
Your answer should be very brief. 0.36. What is the difference between the highest and the lowest ODA received (in %) of 1960?
Ensure brevity in your answer.  11.01. What is the difference between the highest and the lowest ODA received (in %) of 1961?
Offer a terse response. 14.39. What is the difference between the highest and the lowest ODA received (in %) of 1962?
Your answer should be very brief. 17.21. What is the difference between the highest and the lowest ODA received (in %) of 1963?
Your answer should be compact. 11.59. 